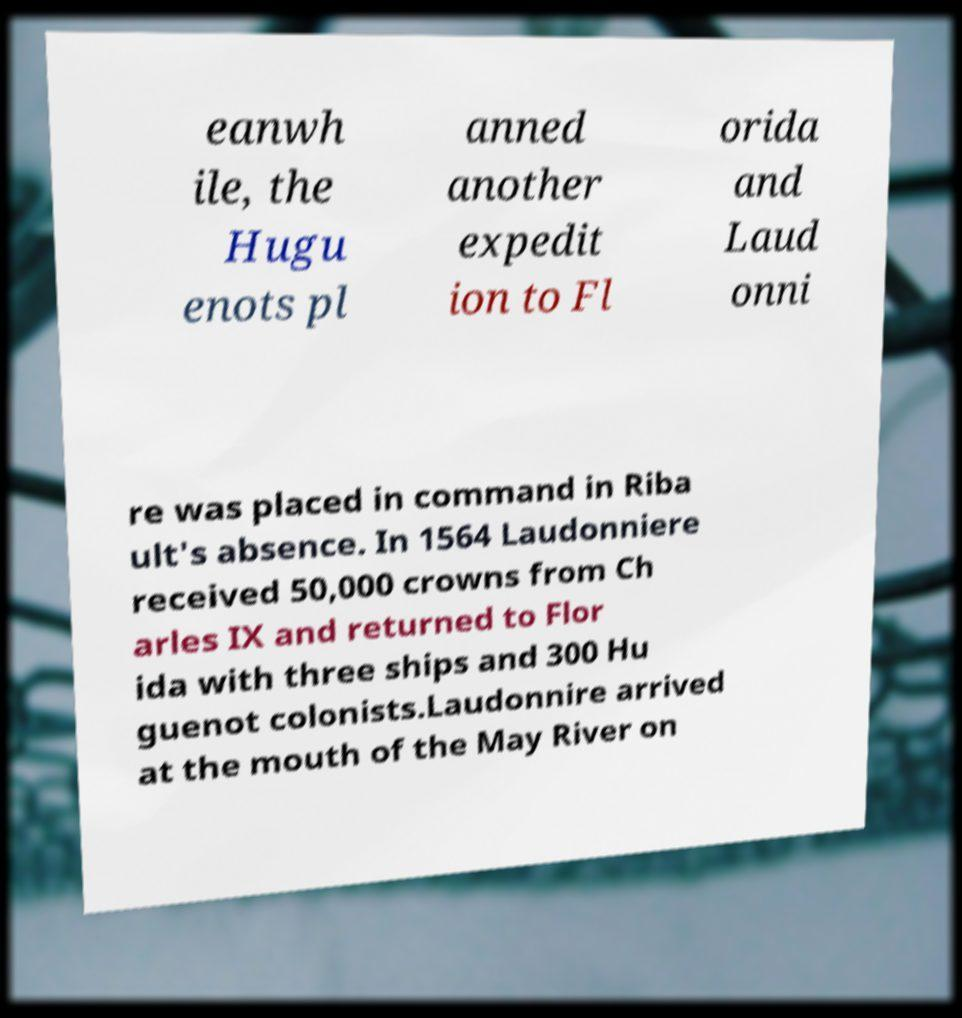There's text embedded in this image that I need extracted. Can you transcribe it verbatim? eanwh ile, the Hugu enots pl anned another expedit ion to Fl orida and Laud onni re was placed in command in Riba ult's absence. In 1564 Laudonniere received 50,000 crowns from Ch arles IX and returned to Flor ida with three ships and 300 Hu guenot colonists.Laudonnire arrived at the mouth of the May River on 